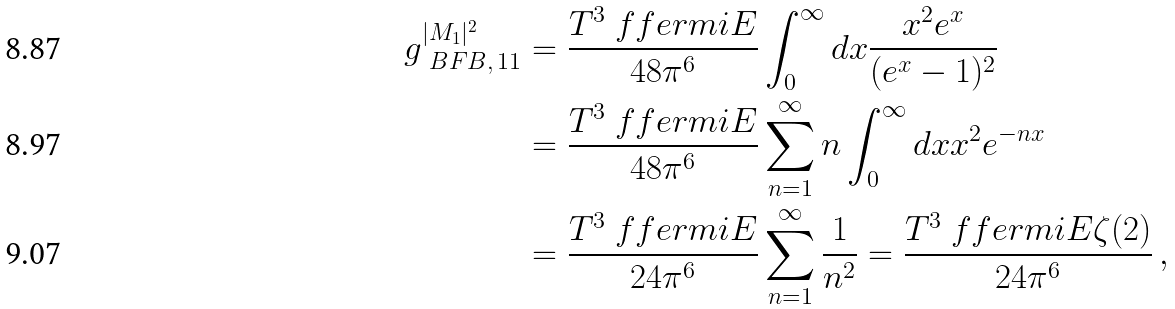<formula> <loc_0><loc_0><loc_500><loc_500>g _ { \ B F B , \, 1 1 } ^ { | M _ { 1 } | ^ { 2 } } & = \frac { T ^ { 3 } \ f f e r m i { E } } { 4 8 \pi ^ { 6 } } \int _ { 0 } ^ { \infty } d x \frac { x ^ { 2 } e ^ { x } } { ( e ^ { x } - 1 ) ^ { 2 } } \\ & = \frac { T ^ { 3 } \ f f e r m i { E } } { 4 8 \pi ^ { 6 } } \sum _ { n = 1 } ^ { \infty } n \int _ { 0 } ^ { \infty } d x x ^ { 2 } e ^ { - n x } \\ & = \frac { T ^ { 3 } \ f f e r m i { E } } { 2 4 \pi ^ { 6 } } \sum _ { n = 1 } ^ { \infty } \frac { 1 } { n ^ { 2 } } = \frac { T ^ { 3 } \ f f e r m i { E } \zeta ( 2 ) } { 2 4 \pi ^ { 6 } } \, ,</formula> 